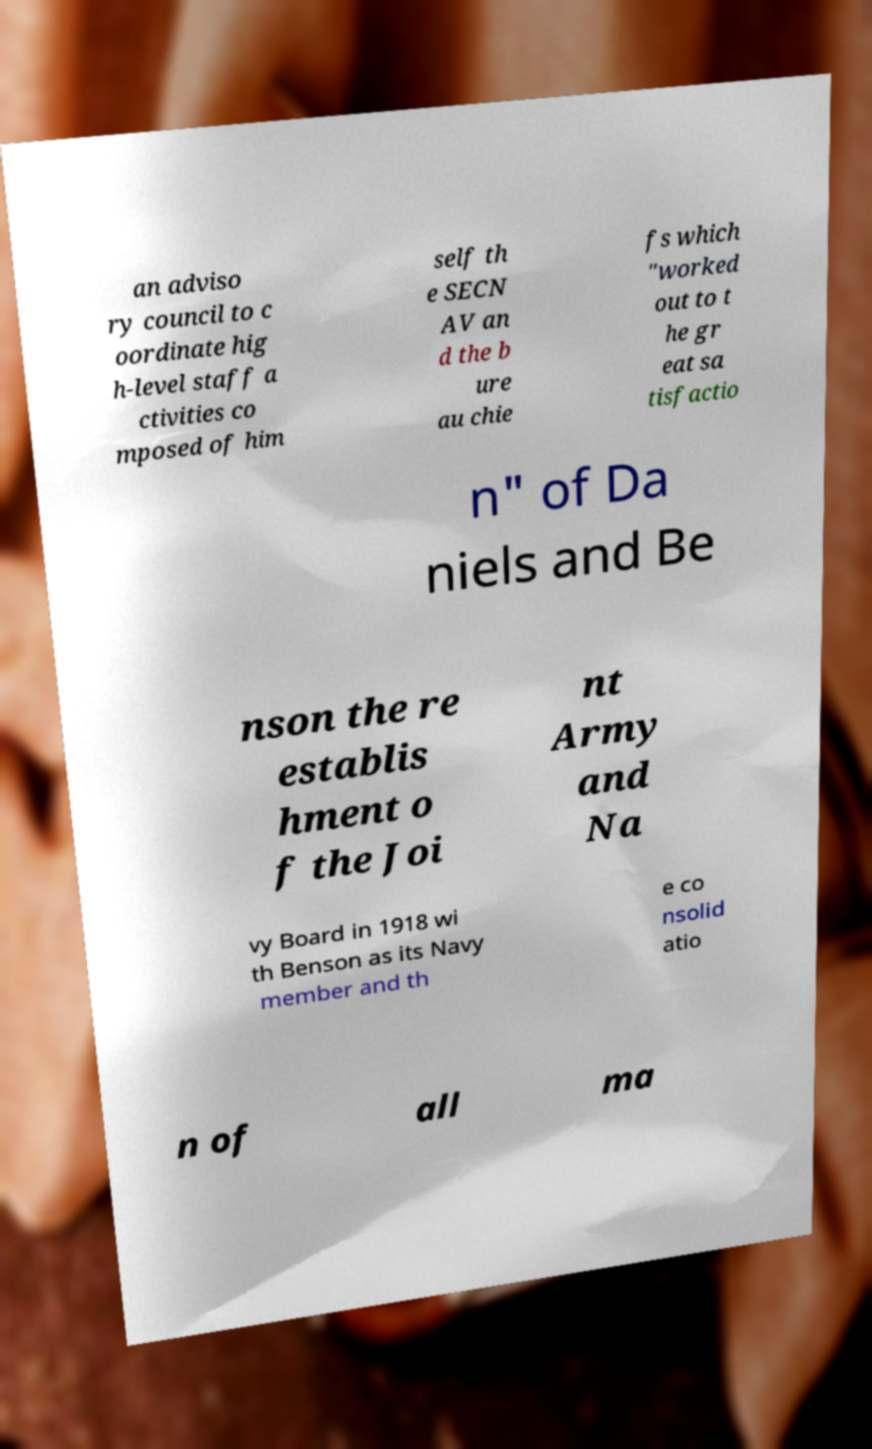Please identify and transcribe the text found in this image. an adviso ry council to c oordinate hig h-level staff a ctivities co mposed of him self th e SECN AV an d the b ure au chie fs which "worked out to t he gr eat sa tisfactio n" of Da niels and Be nson the re establis hment o f the Joi nt Army and Na vy Board in 1918 wi th Benson as its Navy member and th e co nsolid atio n of all ma 